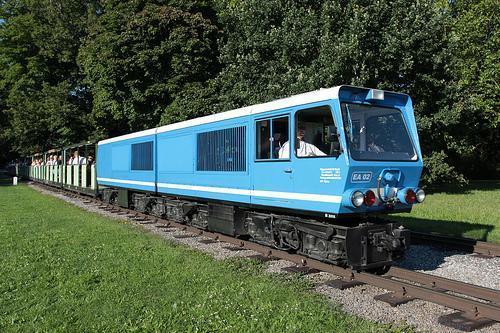How many train cars are blue?
Give a very brief answer. 1. 